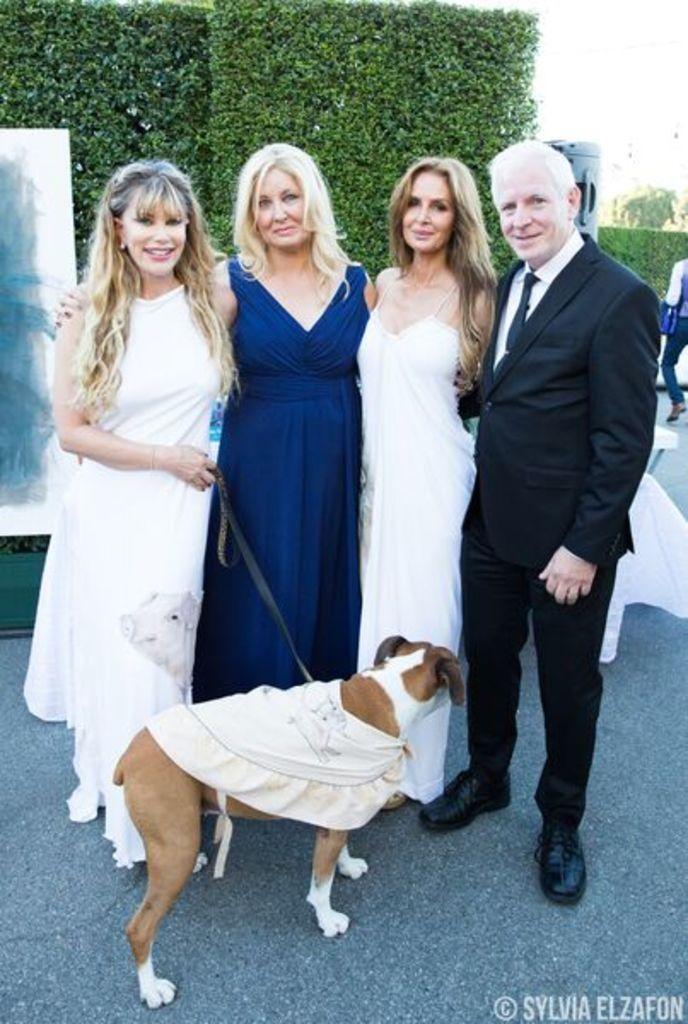Can you describe this image briefly? In the foreground of the picture there are four people and a dog. In the foreground there is road also. In the background there are plants and sky. The man is wearing a black suit. 